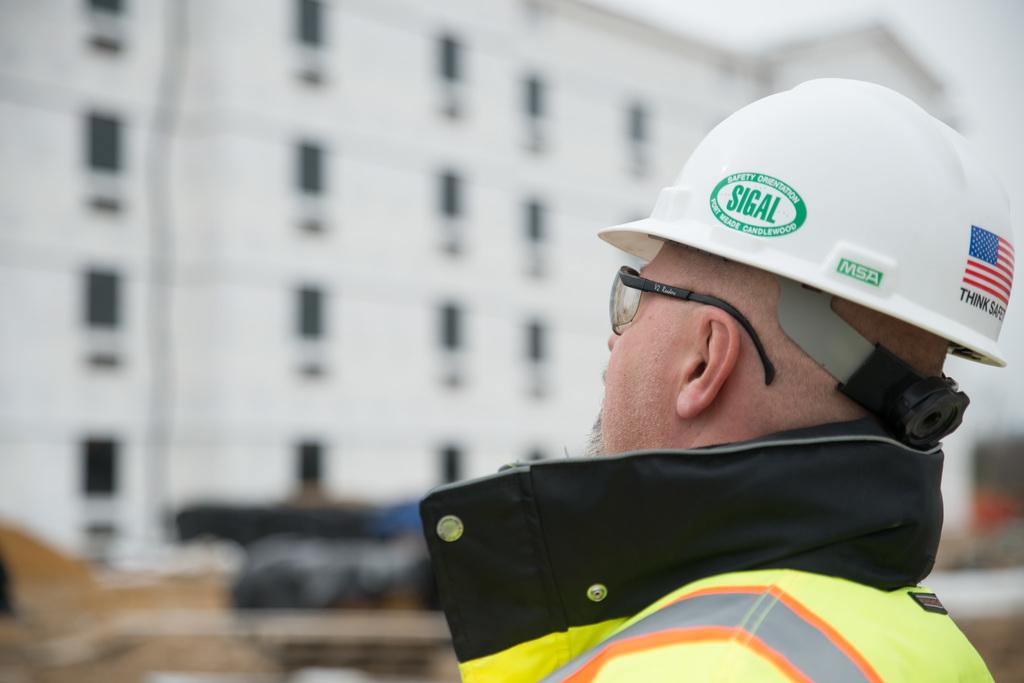Who is present in the image? There is a man in the image. What is the man wearing on his face? The man is wearing glasses. What type of protective gear is the man wearing? The man is wearing a helmet. What can be seen in the background of the image? The background of the image is blurred, but there is a building visible. What type of ocean can be seen in the image? There is no ocean present in the image; it features a man wearing glasses and a helmet with a blurred background and a visible building. 